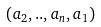Convert formula to latex. <formula><loc_0><loc_0><loc_500><loc_500>( a _ { 2 } , . . , a _ { n } , a _ { 1 } )</formula> 